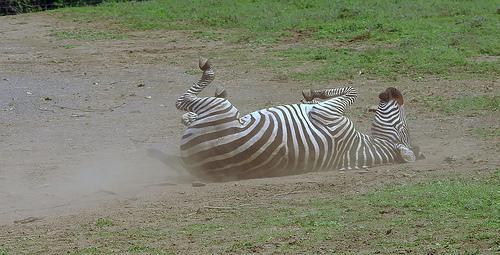How many zebras are there?
Give a very brief answer. 1. 